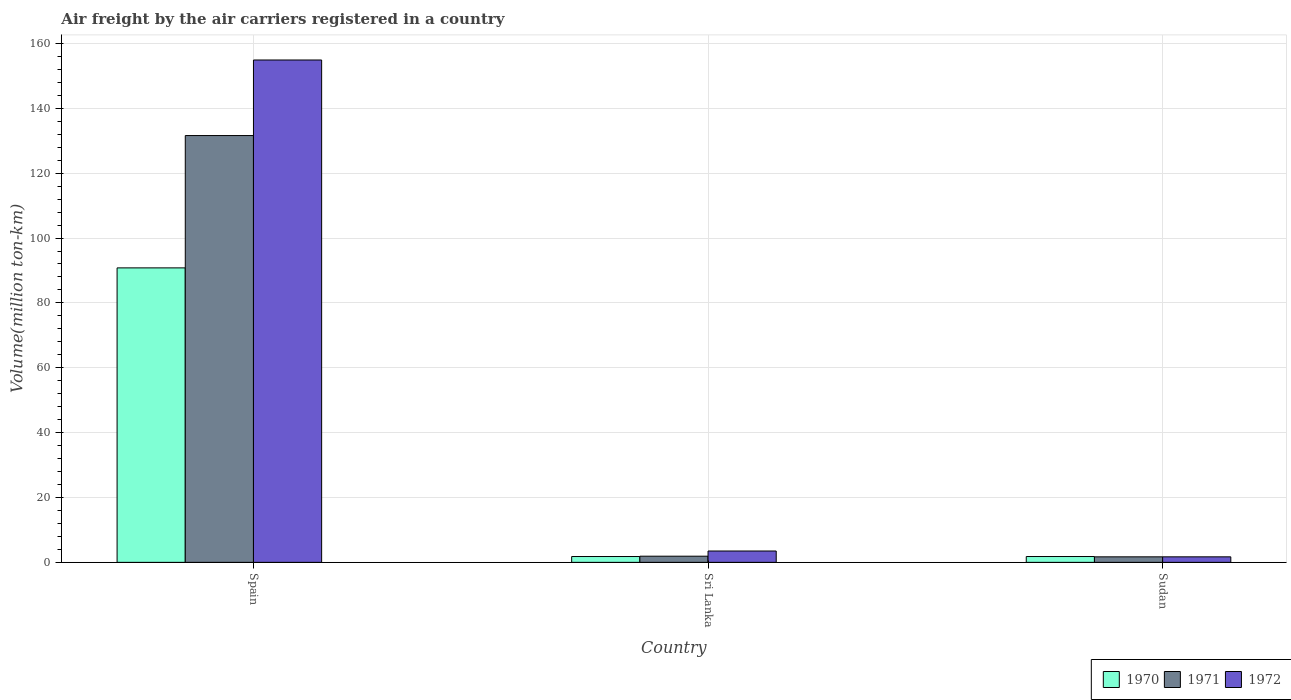How many different coloured bars are there?
Give a very brief answer. 3. How many groups of bars are there?
Ensure brevity in your answer.  3. Are the number of bars per tick equal to the number of legend labels?
Provide a short and direct response. Yes. How many bars are there on the 1st tick from the right?
Provide a succinct answer. 3. What is the label of the 2nd group of bars from the left?
Your answer should be very brief. Sri Lanka. In how many cases, is the number of bars for a given country not equal to the number of legend labels?
Your response must be concise. 0. Across all countries, what is the maximum volume of the air carriers in 1972?
Your answer should be compact. 154.9. Across all countries, what is the minimum volume of the air carriers in 1971?
Ensure brevity in your answer.  1.7. In which country was the volume of the air carriers in 1972 maximum?
Keep it short and to the point. Spain. In which country was the volume of the air carriers in 1971 minimum?
Give a very brief answer. Sudan. What is the total volume of the air carriers in 1970 in the graph?
Your response must be concise. 94.4. What is the difference between the volume of the air carriers in 1971 in Spain and that in Sri Lanka?
Make the answer very short. 129.7. What is the difference between the volume of the air carriers in 1971 in Spain and the volume of the air carriers in 1970 in Sri Lanka?
Provide a succinct answer. 129.8. What is the average volume of the air carriers in 1970 per country?
Give a very brief answer. 31.47. What is the difference between the volume of the air carriers of/in 1970 and volume of the air carriers of/in 1971 in Sudan?
Offer a terse response. 0.1. What is the ratio of the volume of the air carriers in 1971 in Sri Lanka to that in Sudan?
Your answer should be compact. 1.12. What is the difference between the highest and the second highest volume of the air carriers in 1970?
Ensure brevity in your answer.  -89. What is the difference between the highest and the lowest volume of the air carriers in 1971?
Keep it short and to the point. 129.9. In how many countries, is the volume of the air carriers in 1971 greater than the average volume of the air carriers in 1971 taken over all countries?
Keep it short and to the point. 1. What does the 2nd bar from the left in Spain represents?
Offer a very short reply. 1971. Is it the case that in every country, the sum of the volume of the air carriers in 1970 and volume of the air carriers in 1972 is greater than the volume of the air carriers in 1971?
Ensure brevity in your answer.  Yes. What is the difference between two consecutive major ticks on the Y-axis?
Keep it short and to the point. 20. Does the graph contain any zero values?
Ensure brevity in your answer.  No. How are the legend labels stacked?
Your answer should be compact. Horizontal. What is the title of the graph?
Your answer should be very brief. Air freight by the air carriers registered in a country. What is the label or title of the X-axis?
Provide a succinct answer. Country. What is the label or title of the Y-axis?
Provide a succinct answer. Volume(million ton-km). What is the Volume(million ton-km) of 1970 in Spain?
Offer a terse response. 90.8. What is the Volume(million ton-km) in 1971 in Spain?
Give a very brief answer. 131.6. What is the Volume(million ton-km) in 1972 in Spain?
Offer a very short reply. 154.9. What is the Volume(million ton-km) of 1970 in Sri Lanka?
Give a very brief answer. 1.8. What is the Volume(million ton-km) of 1971 in Sri Lanka?
Your response must be concise. 1.9. What is the Volume(million ton-km) in 1972 in Sri Lanka?
Provide a short and direct response. 3.5. What is the Volume(million ton-km) in 1970 in Sudan?
Keep it short and to the point. 1.8. What is the Volume(million ton-km) of 1971 in Sudan?
Make the answer very short. 1.7. What is the Volume(million ton-km) in 1972 in Sudan?
Your response must be concise. 1.7. Across all countries, what is the maximum Volume(million ton-km) in 1970?
Provide a short and direct response. 90.8. Across all countries, what is the maximum Volume(million ton-km) in 1971?
Keep it short and to the point. 131.6. Across all countries, what is the maximum Volume(million ton-km) of 1972?
Your answer should be compact. 154.9. Across all countries, what is the minimum Volume(million ton-km) in 1970?
Provide a succinct answer. 1.8. Across all countries, what is the minimum Volume(million ton-km) of 1971?
Offer a very short reply. 1.7. Across all countries, what is the minimum Volume(million ton-km) in 1972?
Ensure brevity in your answer.  1.7. What is the total Volume(million ton-km) in 1970 in the graph?
Give a very brief answer. 94.4. What is the total Volume(million ton-km) of 1971 in the graph?
Make the answer very short. 135.2. What is the total Volume(million ton-km) in 1972 in the graph?
Give a very brief answer. 160.1. What is the difference between the Volume(million ton-km) of 1970 in Spain and that in Sri Lanka?
Your answer should be compact. 89. What is the difference between the Volume(million ton-km) in 1971 in Spain and that in Sri Lanka?
Keep it short and to the point. 129.7. What is the difference between the Volume(million ton-km) in 1972 in Spain and that in Sri Lanka?
Offer a terse response. 151.4. What is the difference between the Volume(million ton-km) in 1970 in Spain and that in Sudan?
Keep it short and to the point. 89. What is the difference between the Volume(million ton-km) of 1971 in Spain and that in Sudan?
Provide a succinct answer. 129.9. What is the difference between the Volume(million ton-km) of 1972 in Spain and that in Sudan?
Your response must be concise. 153.2. What is the difference between the Volume(million ton-km) of 1972 in Sri Lanka and that in Sudan?
Ensure brevity in your answer.  1.8. What is the difference between the Volume(million ton-km) of 1970 in Spain and the Volume(million ton-km) of 1971 in Sri Lanka?
Your answer should be very brief. 88.9. What is the difference between the Volume(million ton-km) of 1970 in Spain and the Volume(million ton-km) of 1972 in Sri Lanka?
Your answer should be very brief. 87.3. What is the difference between the Volume(million ton-km) of 1971 in Spain and the Volume(million ton-km) of 1972 in Sri Lanka?
Make the answer very short. 128.1. What is the difference between the Volume(million ton-km) in 1970 in Spain and the Volume(million ton-km) in 1971 in Sudan?
Make the answer very short. 89.1. What is the difference between the Volume(million ton-km) of 1970 in Spain and the Volume(million ton-km) of 1972 in Sudan?
Give a very brief answer. 89.1. What is the difference between the Volume(million ton-km) of 1971 in Spain and the Volume(million ton-km) of 1972 in Sudan?
Provide a short and direct response. 129.9. What is the difference between the Volume(million ton-km) in 1970 in Sri Lanka and the Volume(million ton-km) in 1971 in Sudan?
Your answer should be very brief. 0.1. What is the difference between the Volume(million ton-km) of 1970 in Sri Lanka and the Volume(million ton-km) of 1972 in Sudan?
Provide a succinct answer. 0.1. What is the difference between the Volume(million ton-km) in 1971 in Sri Lanka and the Volume(million ton-km) in 1972 in Sudan?
Your answer should be very brief. 0.2. What is the average Volume(million ton-km) of 1970 per country?
Your answer should be very brief. 31.47. What is the average Volume(million ton-km) of 1971 per country?
Offer a terse response. 45.07. What is the average Volume(million ton-km) of 1972 per country?
Your answer should be very brief. 53.37. What is the difference between the Volume(million ton-km) of 1970 and Volume(million ton-km) of 1971 in Spain?
Your answer should be compact. -40.8. What is the difference between the Volume(million ton-km) in 1970 and Volume(million ton-km) in 1972 in Spain?
Your response must be concise. -64.1. What is the difference between the Volume(million ton-km) in 1971 and Volume(million ton-km) in 1972 in Spain?
Make the answer very short. -23.3. What is the difference between the Volume(million ton-km) of 1970 and Volume(million ton-km) of 1971 in Sri Lanka?
Provide a short and direct response. -0.1. What is the difference between the Volume(million ton-km) of 1970 and Volume(million ton-km) of 1972 in Sri Lanka?
Give a very brief answer. -1.7. What is the ratio of the Volume(million ton-km) in 1970 in Spain to that in Sri Lanka?
Offer a very short reply. 50.44. What is the ratio of the Volume(million ton-km) in 1971 in Spain to that in Sri Lanka?
Give a very brief answer. 69.26. What is the ratio of the Volume(million ton-km) of 1972 in Spain to that in Sri Lanka?
Provide a short and direct response. 44.26. What is the ratio of the Volume(million ton-km) of 1970 in Spain to that in Sudan?
Keep it short and to the point. 50.44. What is the ratio of the Volume(million ton-km) in 1971 in Spain to that in Sudan?
Offer a very short reply. 77.41. What is the ratio of the Volume(million ton-km) in 1972 in Spain to that in Sudan?
Keep it short and to the point. 91.12. What is the ratio of the Volume(million ton-km) of 1971 in Sri Lanka to that in Sudan?
Provide a succinct answer. 1.12. What is the ratio of the Volume(million ton-km) of 1972 in Sri Lanka to that in Sudan?
Your answer should be compact. 2.06. What is the difference between the highest and the second highest Volume(million ton-km) of 1970?
Offer a terse response. 89. What is the difference between the highest and the second highest Volume(million ton-km) in 1971?
Provide a short and direct response. 129.7. What is the difference between the highest and the second highest Volume(million ton-km) of 1972?
Keep it short and to the point. 151.4. What is the difference between the highest and the lowest Volume(million ton-km) of 1970?
Offer a very short reply. 89. What is the difference between the highest and the lowest Volume(million ton-km) of 1971?
Your answer should be compact. 129.9. What is the difference between the highest and the lowest Volume(million ton-km) in 1972?
Your answer should be very brief. 153.2. 